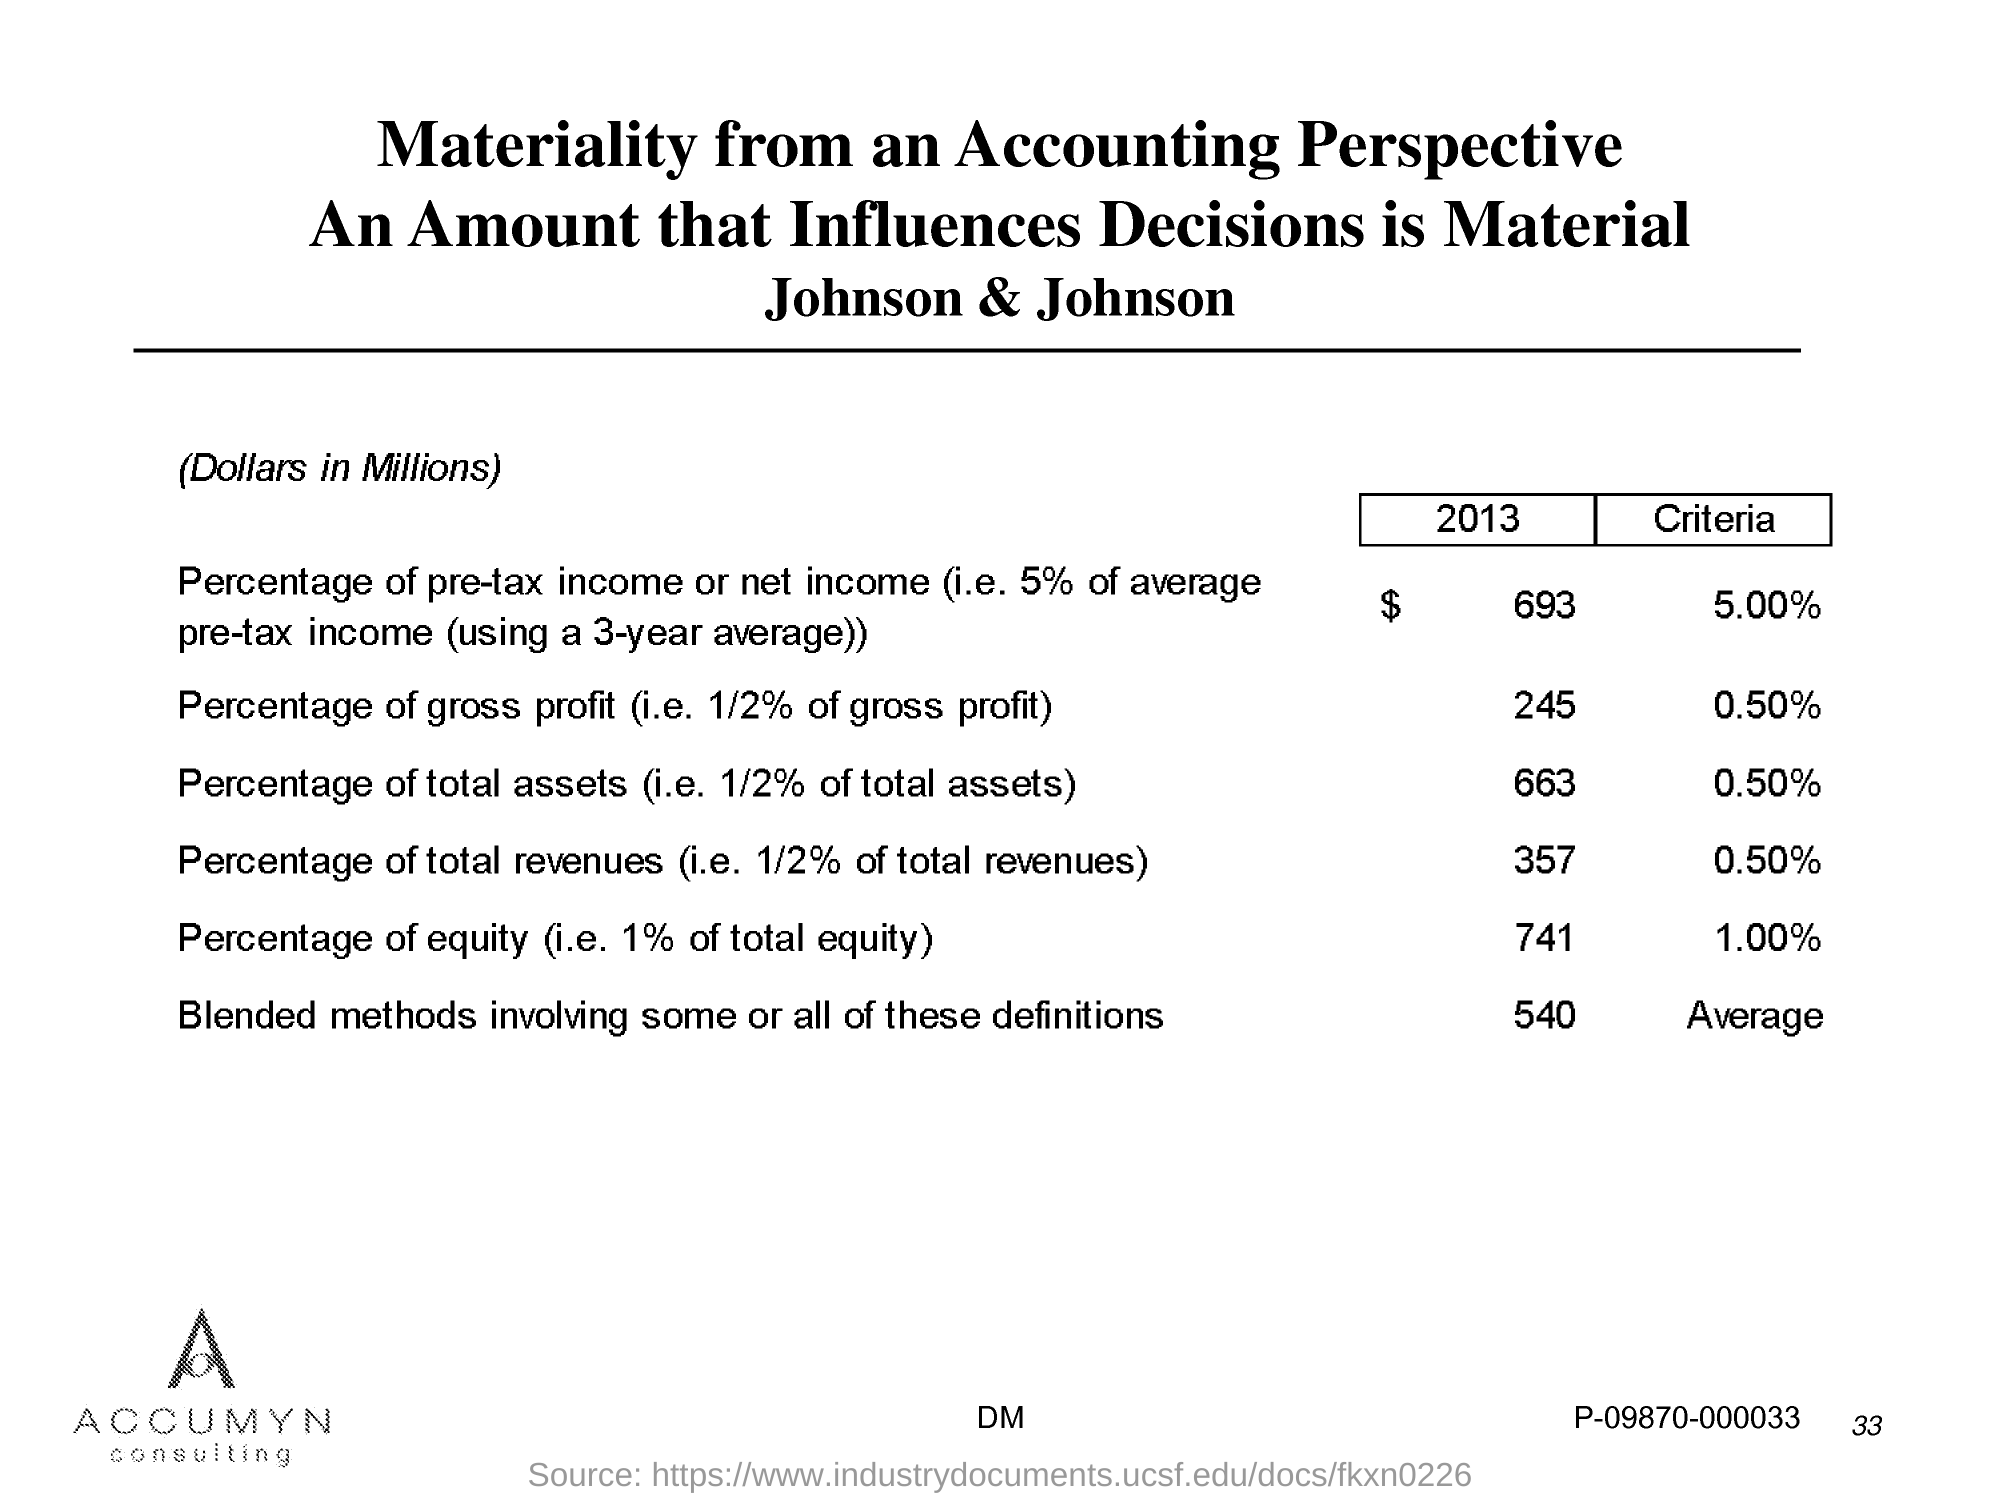What is the Page Number? The page number is 33, as clearly shown in the bottom right of the slide in the presentation. 